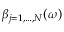Convert formula to latex. <formula><loc_0><loc_0><loc_500><loc_500>\beta _ { j = 1 , \dots , N } ( \omega )</formula> 